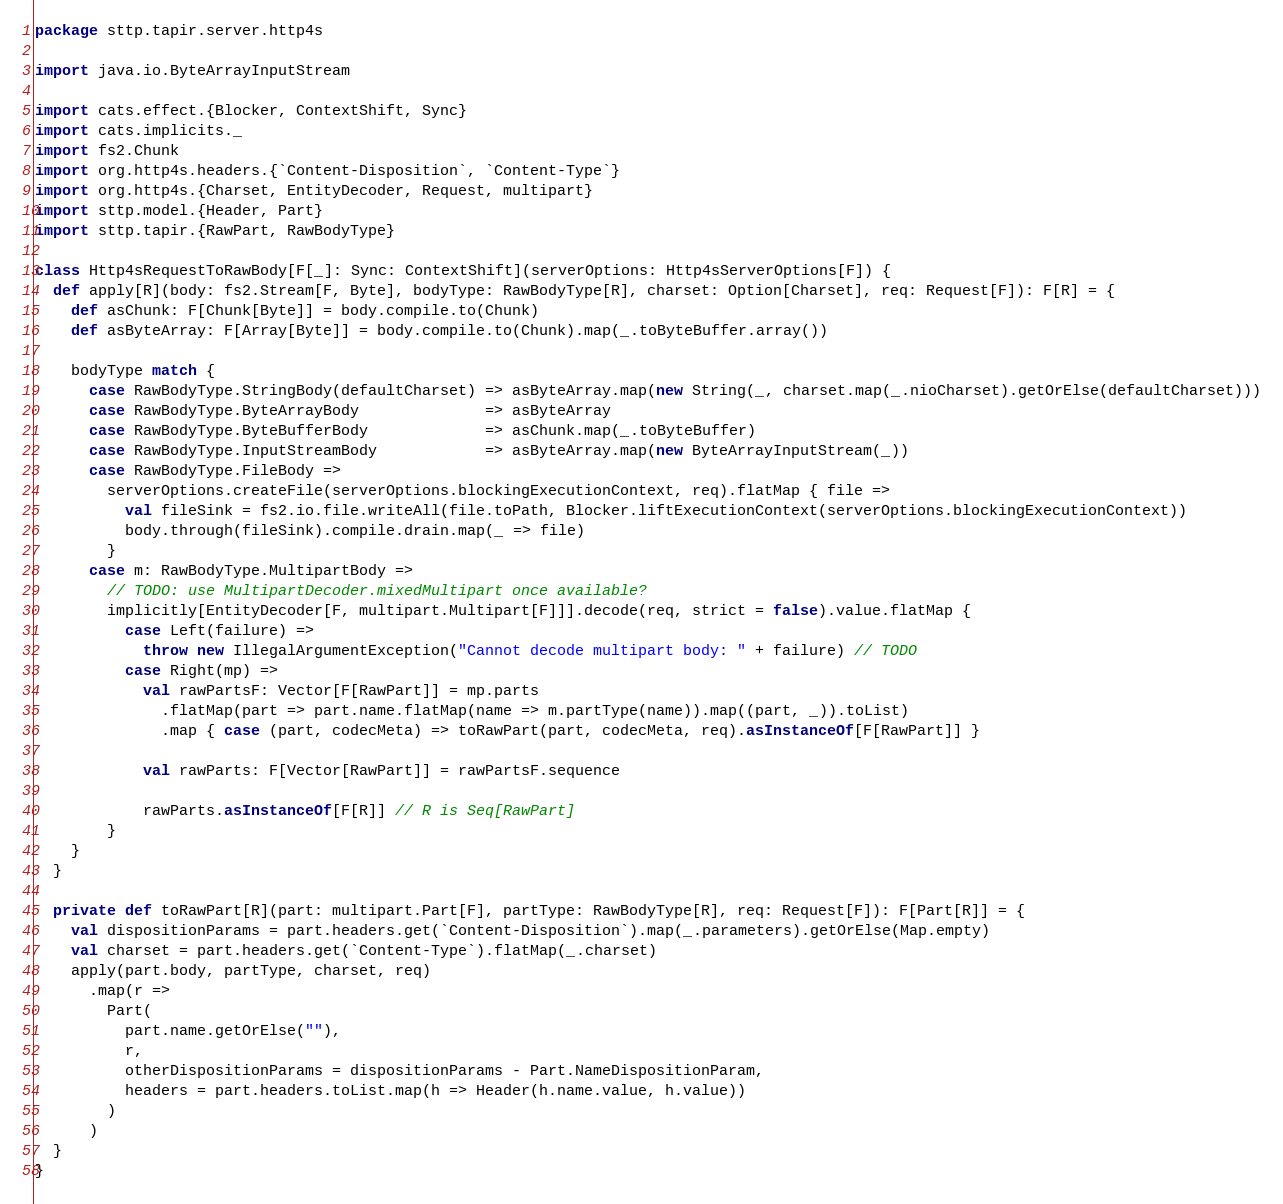<code> <loc_0><loc_0><loc_500><loc_500><_Scala_>package sttp.tapir.server.http4s

import java.io.ByteArrayInputStream

import cats.effect.{Blocker, ContextShift, Sync}
import cats.implicits._
import fs2.Chunk
import org.http4s.headers.{`Content-Disposition`, `Content-Type`}
import org.http4s.{Charset, EntityDecoder, Request, multipart}
import sttp.model.{Header, Part}
import sttp.tapir.{RawPart, RawBodyType}

class Http4sRequestToRawBody[F[_]: Sync: ContextShift](serverOptions: Http4sServerOptions[F]) {
  def apply[R](body: fs2.Stream[F, Byte], bodyType: RawBodyType[R], charset: Option[Charset], req: Request[F]): F[R] = {
    def asChunk: F[Chunk[Byte]] = body.compile.to(Chunk)
    def asByteArray: F[Array[Byte]] = body.compile.to(Chunk).map(_.toByteBuffer.array())

    bodyType match {
      case RawBodyType.StringBody(defaultCharset) => asByteArray.map(new String(_, charset.map(_.nioCharset).getOrElse(defaultCharset)))
      case RawBodyType.ByteArrayBody              => asByteArray
      case RawBodyType.ByteBufferBody             => asChunk.map(_.toByteBuffer)
      case RawBodyType.InputStreamBody            => asByteArray.map(new ByteArrayInputStream(_))
      case RawBodyType.FileBody =>
        serverOptions.createFile(serverOptions.blockingExecutionContext, req).flatMap { file =>
          val fileSink = fs2.io.file.writeAll(file.toPath, Blocker.liftExecutionContext(serverOptions.blockingExecutionContext))
          body.through(fileSink).compile.drain.map(_ => file)
        }
      case m: RawBodyType.MultipartBody =>
        // TODO: use MultipartDecoder.mixedMultipart once available?
        implicitly[EntityDecoder[F, multipart.Multipart[F]]].decode(req, strict = false).value.flatMap {
          case Left(failure) =>
            throw new IllegalArgumentException("Cannot decode multipart body: " + failure) // TODO
          case Right(mp) =>
            val rawPartsF: Vector[F[RawPart]] = mp.parts
              .flatMap(part => part.name.flatMap(name => m.partType(name)).map((part, _)).toList)
              .map { case (part, codecMeta) => toRawPart(part, codecMeta, req).asInstanceOf[F[RawPart]] }

            val rawParts: F[Vector[RawPart]] = rawPartsF.sequence

            rawParts.asInstanceOf[F[R]] // R is Seq[RawPart]
        }
    }
  }

  private def toRawPart[R](part: multipart.Part[F], partType: RawBodyType[R], req: Request[F]): F[Part[R]] = {
    val dispositionParams = part.headers.get(`Content-Disposition`).map(_.parameters).getOrElse(Map.empty)
    val charset = part.headers.get(`Content-Type`).flatMap(_.charset)
    apply(part.body, partType, charset, req)
      .map(r =>
        Part(
          part.name.getOrElse(""),
          r,
          otherDispositionParams = dispositionParams - Part.NameDispositionParam,
          headers = part.headers.toList.map(h => Header(h.name.value, h.value))
        )
      )
  }
}
</code> 